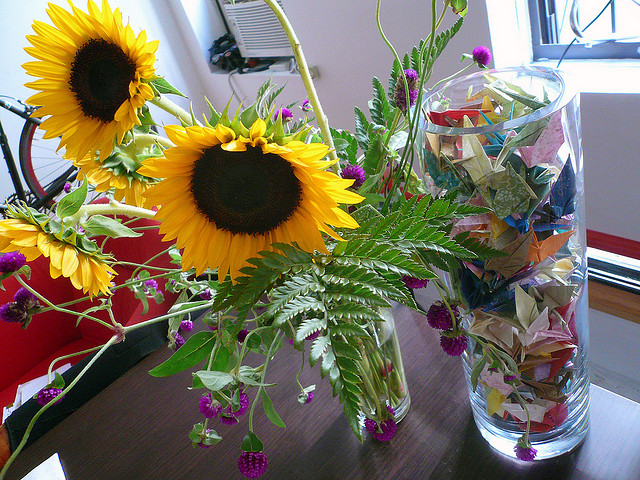<image>England's Queen mother and these blooms share what syllable? It's unknown what syllable England's Queen mother and these blooms share. The answer could be 'sun', 's', or 'elizabeth'. England's Queen mother and these blooms share what syllable? I don't know the syllable that England's Queen mother and these blooms share. It could be 'sun', but I am not sure. 